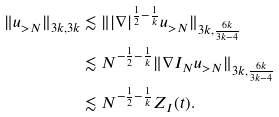Convert formula to latex. <formula><loc_0><loc_0><loc_500><loc_500>\| u _ { > N } \| _ { 3 k , 3 k } & \lesssim \| | \nabla | ^ { \frac { 1 } { 2 } - \frac { 1 } { k } } u _ { > N } \| _ { 3 k , \frac { 6 k } { 3 k - 4 } } \\ & \lesssim N ^ { - \frac { 1 } { 2 } - \frac { 1 } { k } } \| \nabla I _ { N } u _ { > N } \| _ { 3 k , \frac { 6 k } { 3 k - 4 } } \\ & \lesssim N ^ { - \frac { 1 } { 2 } - \frac { 1 } { k } } Z _ { I } ( t ) .</formula> 